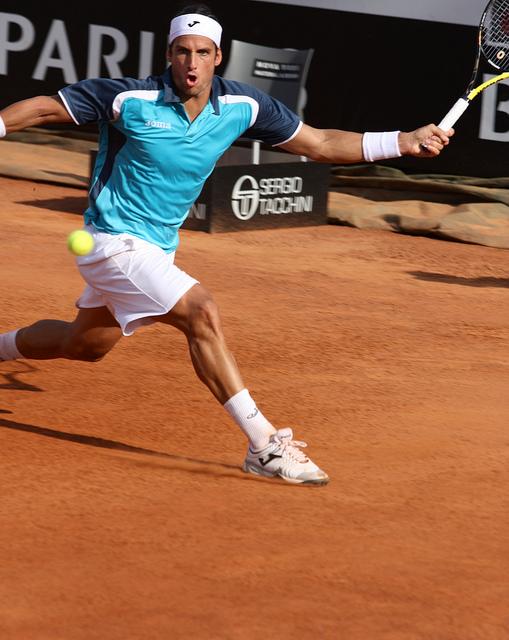What sport are they playing?
Short answer required. Tennis. What is he wearing on his head?
Give a very brief answer. Headband. What hand is the man holding the tennis racquet in?
Keep it brief. Left. How high in the air is the blue shirted man?
Keep it brief. On ground. Is the man's mouth open or closed?
Give a very brief answer. Open. 